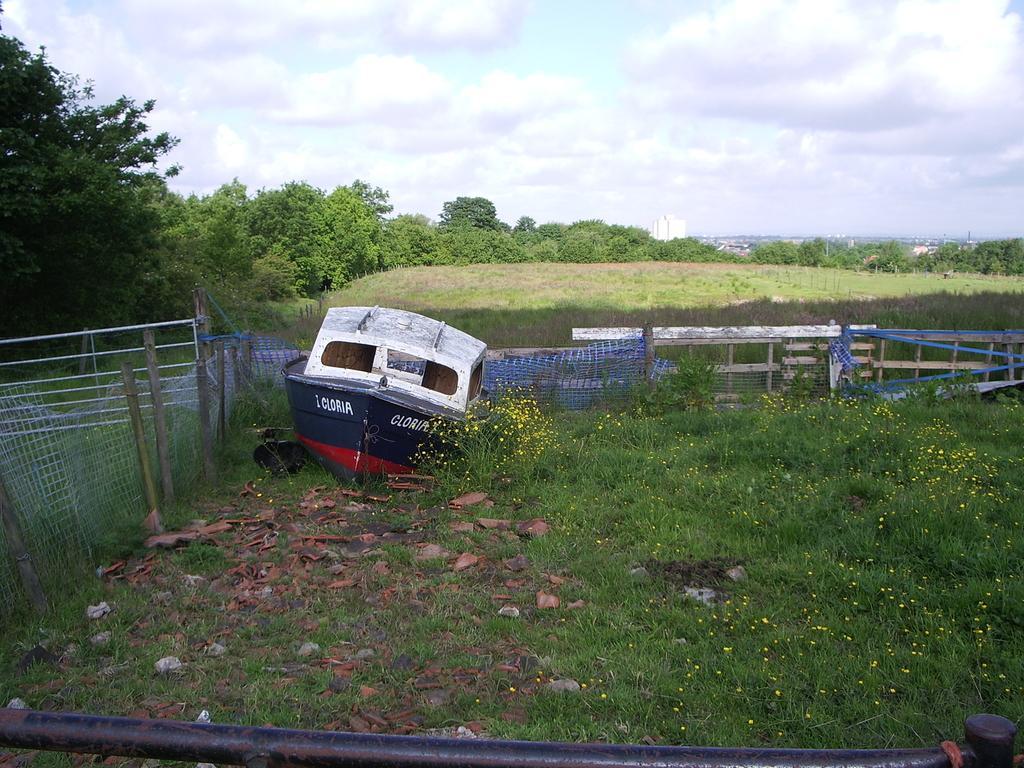Could you give a brief overview of what you see in this image? In this image we can see a boat, plants, stones and also grass. We can also see the fence and behind the fence we can see many trees. There is sky with the clouds. At the bottom we can see the road. 